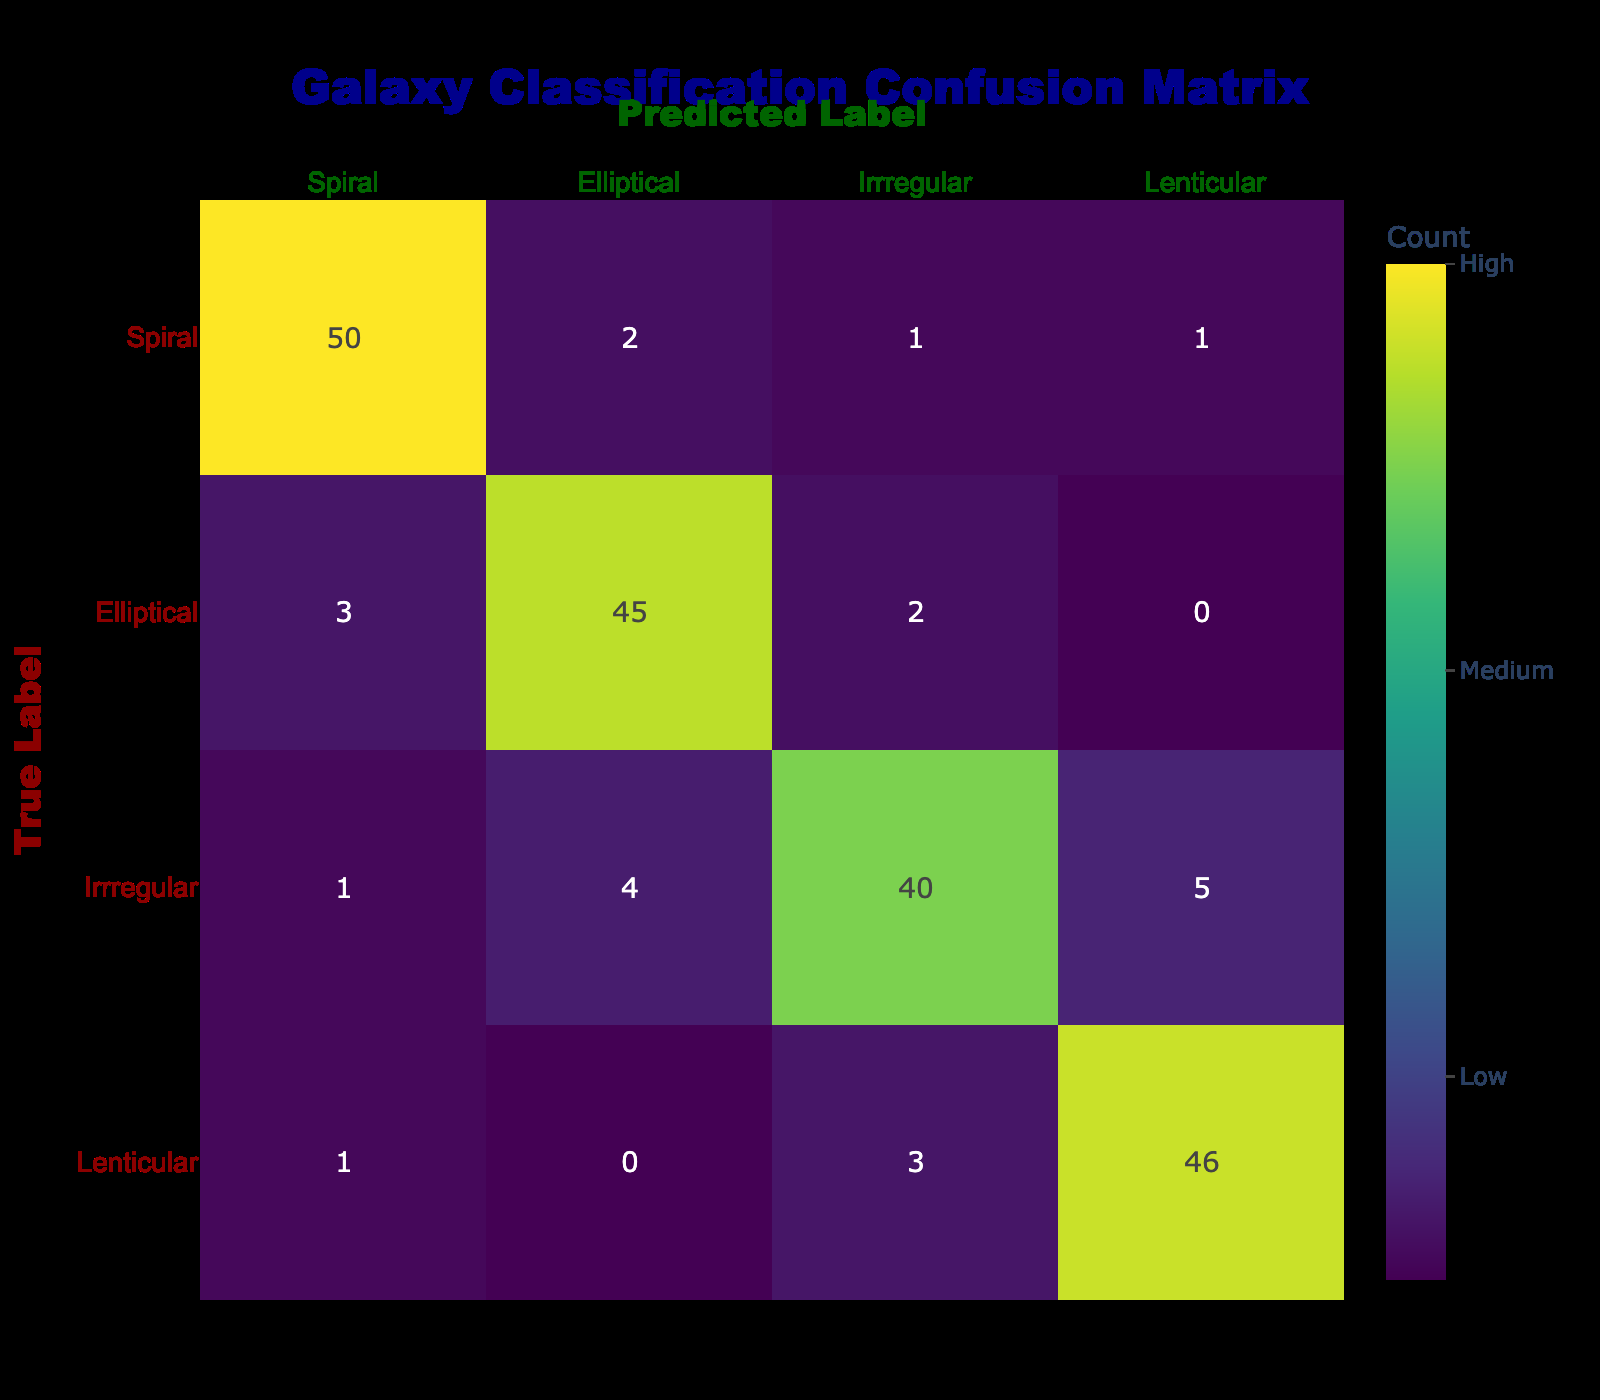What is the number of correctly classified Spiral galaxies? The correctly classified Spiral galaxies are found on the diagonal of the confusion matrix. The value for Spiral galaxies under the True Label row and Spiral column is 50.
Answer: 50 What is the total number of Irregular galaxies predicted as Spiral? The value predicted as Spiral for Irregular galaxies can be found at the intersection of the True Label row for Irregular and the predicted column for Spiral. This value is 1.
Answer: 1 What is the average number of misclassifications for each galaxy type? The misclassifications can be calculated for each galaxy type by summing the off-diagonal values in each row. For Spiral, misclassifications = 2 + 1 + 1 = 4; for Elliptical, misclassifications = 3 + 2 + 0 = 5; for Irregular, misclassifications = 1 + 4 + 5 = 10; for Lenticular, misclassifications = 1 + 0 + 3 = 4. The total misclassifications = 4 + 5 + 10 + 4 = 23. The average misclassifications = 23/4 = 5.75.
Answer: 5.75 Is the number of correctly classified galaxies for Elliptical greater than for Irregular? The number of correctly classified Elliptical galaxies is found at the intersection of the True Label row for Elliptical and the predicted column for Elliptical, which is 45. For Irregular, it is 40. Since 45 is greater than 40, the statement is true.
Answer: Yes What is the total number of galaxies classified as Lenticular? The total can be found by summing all predicted classifications for Lenticular: 1 (Spiral) + 0 (Elliptical) + 3 (Irregular) + 46 (Lenticular) = 50.
Answer: 50 How many more Spiral galaxies were correctly classified than Irregular galaxies? The correctly classified Spiral galaxies are 50, and the correctly classified Irregular galaxies are 40. The difference is 50 - 40 = 10.
Answer: 10 What percentage of total predictions were correctly classified as Spiral? To find the percentage, take the number of correctly classified Spiral galaxies (50) and divide it by the total predictions for Spiral (50 + 2 + 1 + 1 = 54). Therefore, the percentage is (50 / 54) * 100 ≈ 92.59%.
Answer: 92.59% True or False: There are more than 40 Irregular galaxies classified as something other than Irregular. Looking at the Irregular row, the values predicted as Spiral (1), Elliptical (4), and Lenticular (5) total 10. Since 10 is less than 40, the statement is false.
Answer: False 